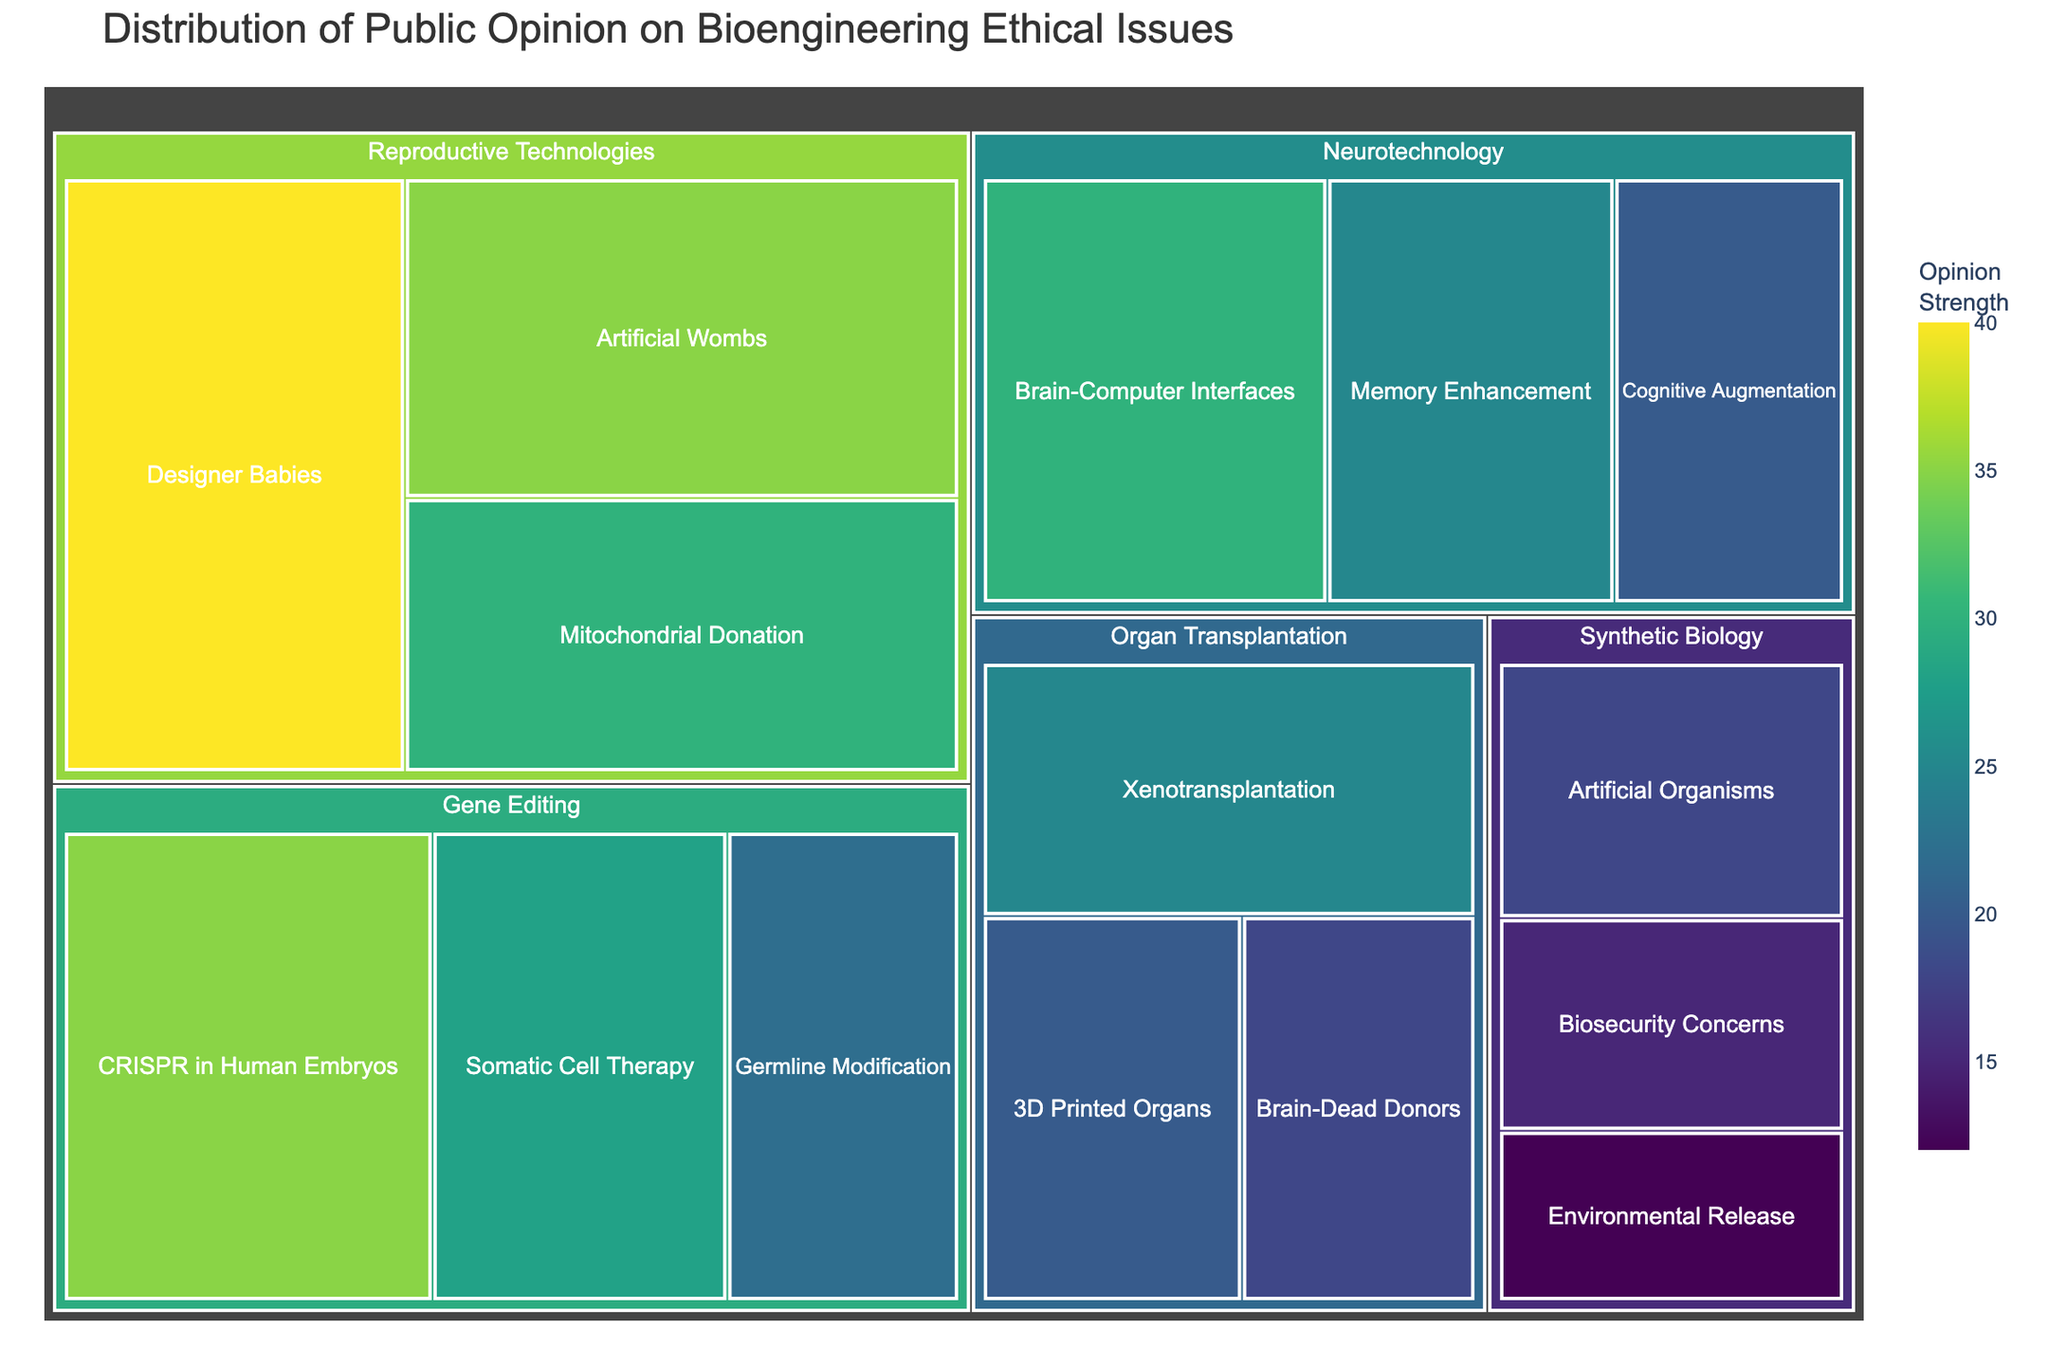What is the title of the treemap? The treemap's title is located at the top of the plot, usually in larger and bold font. Here, the title reads "Distribution of Public Opinion on Bioengineering Ethical Issues."
Answer: Distribution of Public Opinion on Bioengineering Ethical Issues Which subcategory has the highest value in the Gene Editing category? Within the Gene Editing category, the subcategories are CRISPR in Human Embryos, Somatic Cell Therapy, and Germline Modification. By noting their values, CRISPR in Human Embryos has the highest value of 35.
Answer: CRISPR in Human Embryos How many subcategories are there in total across all categories? To determine the total number of subcategories, count each subcategory under every category in the treemap. Here, there are 3 subcategories in Gene Editing, 3 in Synthetic Biology, 3 in Organ Transplantation, 3 in Neurotechnology, and 3 in Reproductive Technologies. Adding these gives 15 subcategories.
Answer: 15 Which category has the highest overall sum of public opinion values? Calculate the total for each category by summing the values of its subcategories. Gene Editing's total is 35 + 28 + 22 = 85, Synthetic Biology's is 18 + 15 + 12 = 45, Organ Transplantation's is 25 + 20 + 18 = 63, Neurotechnology's is 30 + 25 + 20 = 75, and Reproductive Technologies' is 40 + 35 + 30 = 105. Therefore, Reproductive Technologies has the highest total.
Answer: Reproductive Technologies What is the difference in values between Designer Babies and Brain-Dead Donors? Identify the values for both subcategories: Designer Babies has a value of 40, and Brain-Dead Donors has a value of 18. The difference is 40 - 18 = 22.
Answer: 22 Which subcategory holds the lowest public opinion value, and what is its category? Scan all subcategories' values to find the smallest one, which is 12. This value corresponds to Environmental Release within the Synthetic Biology category.
Answer: Environmental Release, Synthetic Biology Is the public opinion value for CRISPR in Human Embryos greater than that for 3D Printed Organs? Compare the values of both subcategories. CRISPR in Human Embryos has a value of 35, while 3D Printed Organs has a value of 20. Since 35 is greater than 20, the answer is yes.
Answer: Yes What is the average public opinion value of the subcategories in the Neurotechnology category? Sum up the values of the Neurotechnology subcategories (30 for Brain-Computer Interfaces, 25 for Memory Enhancement, and 20 for Cognitive Augmentation), resulting in 30 + 25 + 20 = 75. Divide this sum by the number of subcategories, which is 75 / 3 = 25.
Answer: 25 Which category has the smallest range of public opinion values? Calculate the range of values for each category by subtracting the smallest value from the largest value within each category. Gene Editing: 35 - 22 = 13, Synthetic Biology: 18 - 12 = 6, Organ Transplantation: 25 - 18 = 7, Neurotechnology: 30 - 20 = 10, Reproductive Technologies: 40 - 30 = 10. Synthetic Biology has the smallest range.
Answer: Synthetic Biology 